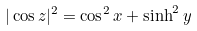<formula> <loc_0><loc_0><loc_500><loc_500>| \cos z | ^ { 2 } = \cos ^ { 2 } x + \sinh ^ { 2 } y</formula> 